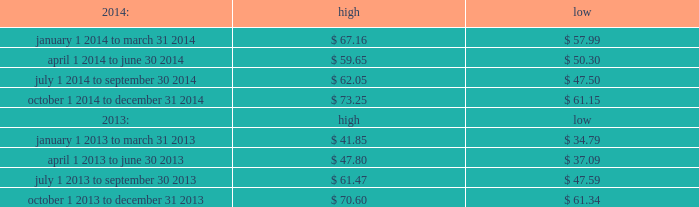Part ii item 5 .
Market for registrant 2019s common equity , related stockholder matters and issuer purchases of equity securities .
Price range our common stock trades on the nasdaq global select market under the symbol 201cmktx 201d .
The range of closing price information for our common stock , as reported by nasdaq , was as follows : on february 20 , 2015 , the last reported closing price of our common stock on the nasdaq global select market was $ 78.97 .
Holders there were 28 holders of record of our common stock as of february 20 , 2015 .
Dividend policy during 2014 , 2013 and 2012 , we paid quarterly cash dividends of $ 0.16 per share , $ 0.13 per share and $ 0.11 per share , respectively .
On december 27 , 2012 , we paid a special cash dividend of $ 1.30 per share .
In january 2015 , our board of directors approved a quarterly cash dividend of $ 0.20 per share payable on february 26 , 2015 to stockholders of record as of the close of business on february 12 , 2015 .
Any future declaration and payment of dividends will be at the sole discretion of our board of directors .
The board of directors may take into account such matters as general business conditions , our financial results , capital requirements , contractual obligations , legal and regulatory restrictions on the payment of dividends to our stockholders or by our subsidiaries to their respective parent entities , and such other factors as the board of directors may deem relevant .
Recent sales of unregistered securities securities authorized for issuance under equity compensation plans please see the section entitled 201cequity compensation plan information 201d in item 12. .

Between july 1 2014 to september 30 2014 what was the spread between the high and low price per share? 
Computations: (62.05 - 47.50)
Answer: 14.55. 